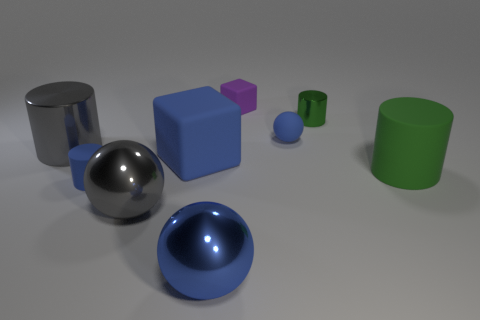Subtract all tiny matte balls. How many balls are left? 2 Subtract 3 cylinders. How many cylinders are left? 1 Add 1 tiny metal objects. How many objects exist? 10 Subtract all gray spheres. How many spheres are left? 2 Subtract all cubes. How many objects are left? 7 Subtract all yellow balls. Subtract all gray cylinders. How many balls are left? 3 Subtract all yellow balls. How many blue cylinders are left? 1 Subtract all tiny blocks. Subtract all blue rubber blocks. How many objects are left? 7 Add 1 big blue cubes. How many big blue cubes are left? 2 Add 5 large green matte objects. How many large green matte objects exist? 6 